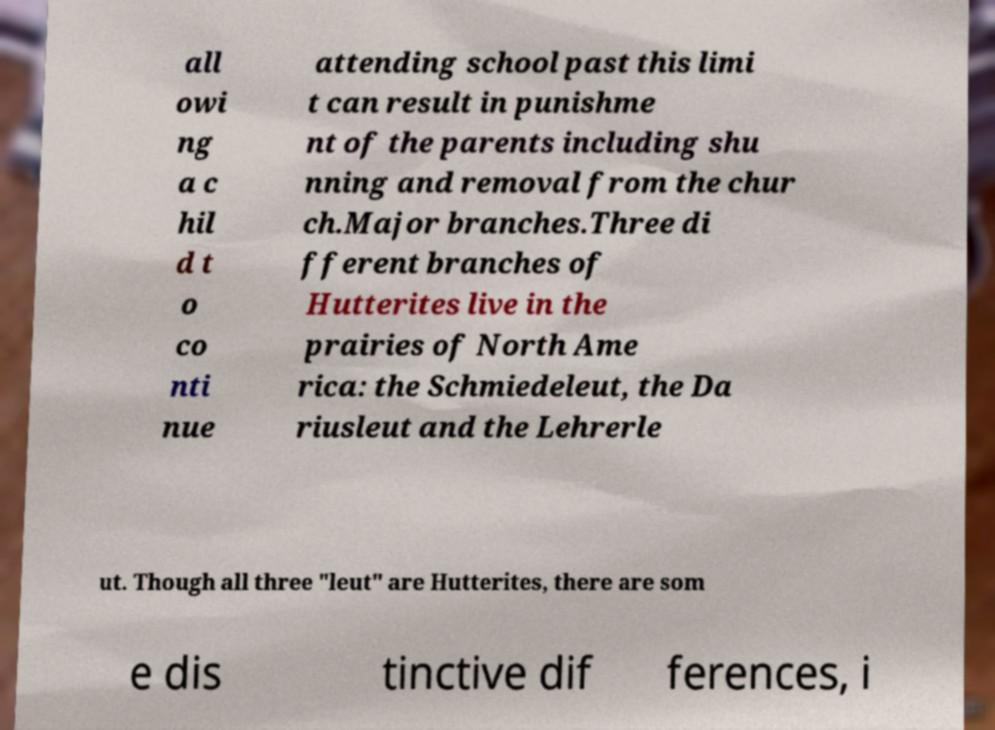Please identify and transcribe the text found in this image. all owi ng a c hil d t o co nti nue attending school past this limi t can result in punishme nt of the parents including shu nning and removal from the chur ch.Major branches.Three di fferent branches of Hutterites live in the prairies of North Ame rica: the Schmiedeleut, the Da riusleut and the Lehrerle ut. Though all three "leut" are Hutterites, there are som e dis tinctive dif ferences, i 